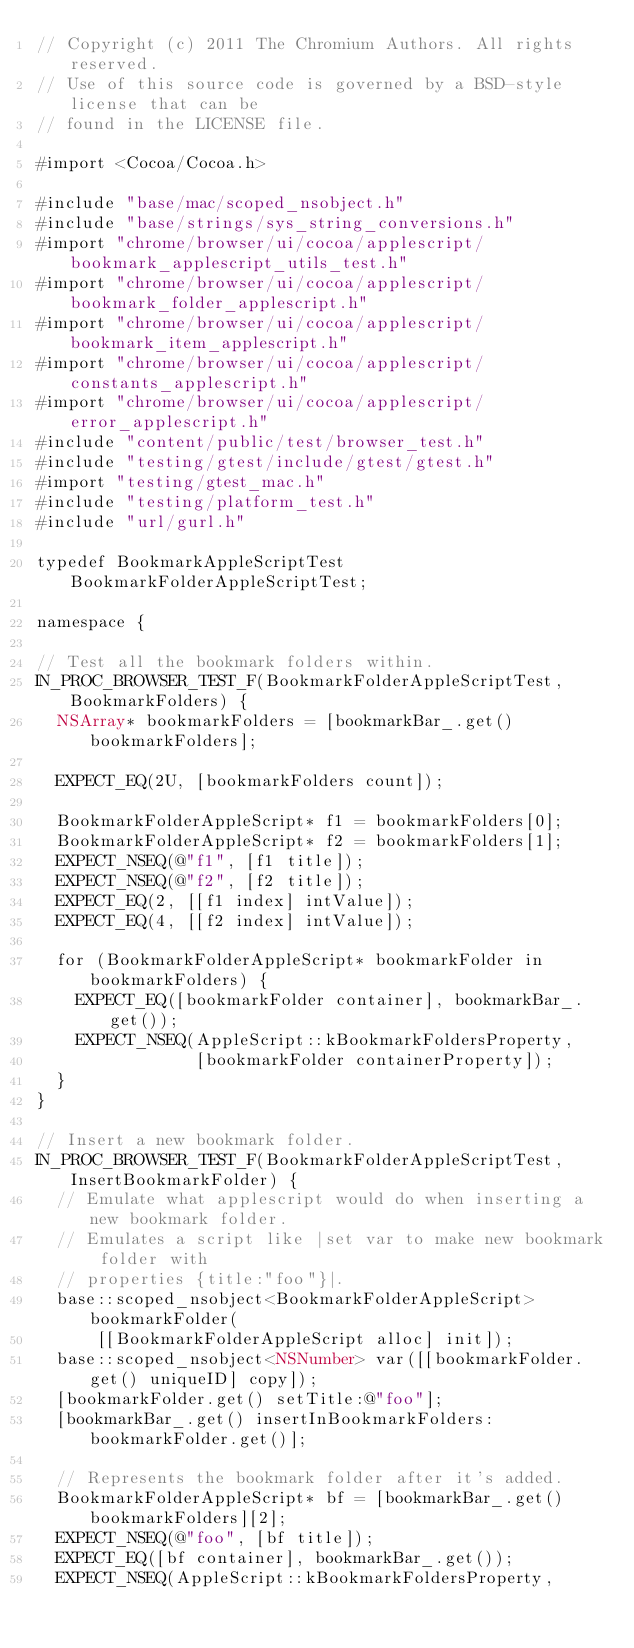Convert code to text. <code><loc_0><loc_0><loc_500><loc_500><_ObjectiveC_>// Copyright (c) 2011 The Chromium Authors. All rights reserved.
// Use of this source code is governed by a BSD-style license that can be
// found in the LICENSE file.

#import <Cocoa/Cocoa.h>

#include "base/mac/scoped_nsobject.h"
#include "base/strings/sys_string_conversions.h"
#import "chrome/browser/ui/cocoa/applescript/bookmark_applescript_utils_test.h"
#import "chrome/browser/ui/cocoa/applescript/bookmark_folder_applescript.h"
#import "chrome/browser/ui/cocoa/applescript/bookmark_item_applescript.h"
#import "chrome/browser/ui/cocoa/applescript/constants_applescript.h"
#import "chrome/browser/ui/cocoa/applescript/error_applescript.h"
#include "content/public/test/browser_test.h"
#include "testing/gtest/include/gtest/gtest.h"
#import "testing/gtest_mac.h"
#include "testing/platform_test.h"
#include "url/gurl.h"

typedef BookmarkAppleScriptTest BookmarkFolderAppleScriptTest;

namespace {

// Test all the bookmark folders within.
IN_PROC_BROWSER_TEST_F(BookmarkFolderAppleScriptTest, BookmarkFolders) {
  NSArray* bookmarkFolders = [bookmarkBar_.get() bookmarkFolders];

  EXPECT_EQ(2U, [bookmarkFolders count]);

  BookmarkFolderAppleScript* f1 = bookmarkFolders[0];
  BookmarkFolderAppleScript* f2 = bookmarkFolders[1];
  EXPECT_NSEQ(@"f1", [f1 title]);
  EXPECT_NSEQ(@"f2", [f2 title]);
  EXPECT_EQ(2, [[f1 index] intValue]);
  EXPECT_EQ(4, [[f2 index] intValue]);

  for (BookmarkFolderAppleScript* bookmarkFolder in bookmarkFolders) {
    EXPECT_EQ([bookmarkFolder container], bookmarkBar_.get());
    EXPECT_NSEQ(AppleScript::kBookmarkFoldersProperty,
                [bookmarkFolder containerProperty]);
  }
}

// Insert a new bookmark folder.
IN_PROC_BROWSER_TEST_F(BookmarkFolderAppleScriptTest, InsertBookmarkFolder) {
  // Emulate what applescript would do when inserting a new bookmark folder.
  // Emulates a script like |set var to make new bookmark folder with
  // properties {title:"foo"}|.
  base::scoped_nsobject<BookmarkFolderAppleScript> bookmarkFolder(
      [[BookmarkFolderAppleScript alloc] init]);
  base::scoped_nsobject<NSNumber> var([[bookmarkFolder.get() uniqueID] copy]);
  [bookmarkFolder.get() setTitle:@"foo"];
  [bookmarkBar_.get() insertInBookmarkFolders:bookmarkFolder.get()];

  // Represents the bookmark folder after it's added.
  BookmarkFolderAppleScript* bf = [bookmarkBar_.get() bookmarkFolders][2];
  EXPECT_NSEQ(@"foo", [bf title]);
  EXPECT_EQ([bf container], bookmarkBar_.get());
  EXPECT_NSEQ(AppleScript::kBookmarkFoldersProperty,</code> 